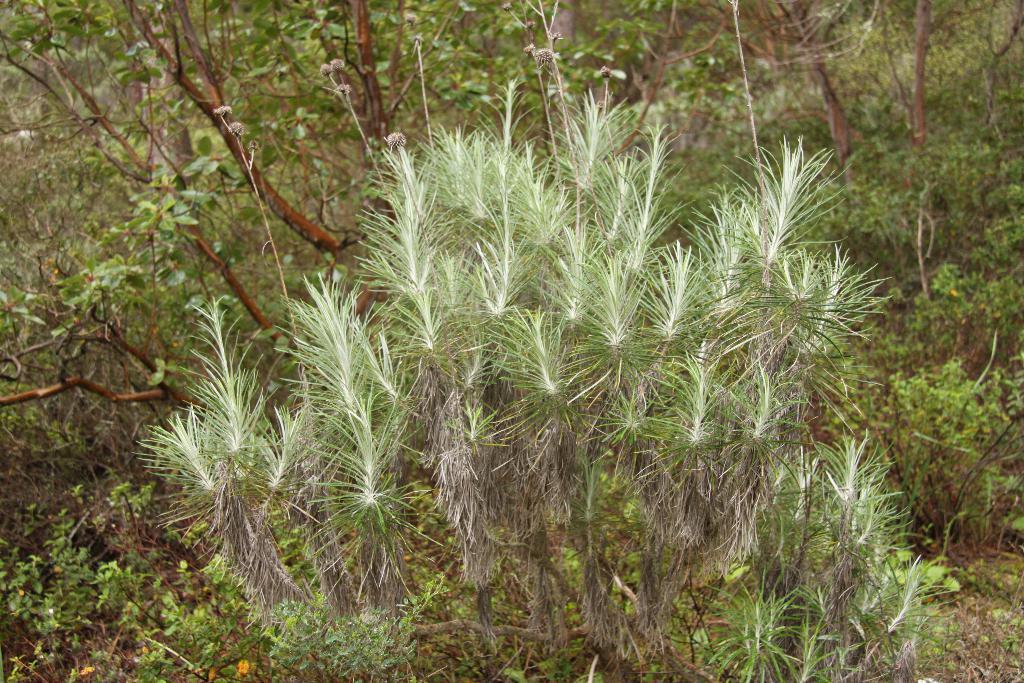Describe this image in one or two sentences. In this picture we can see a few plants. 